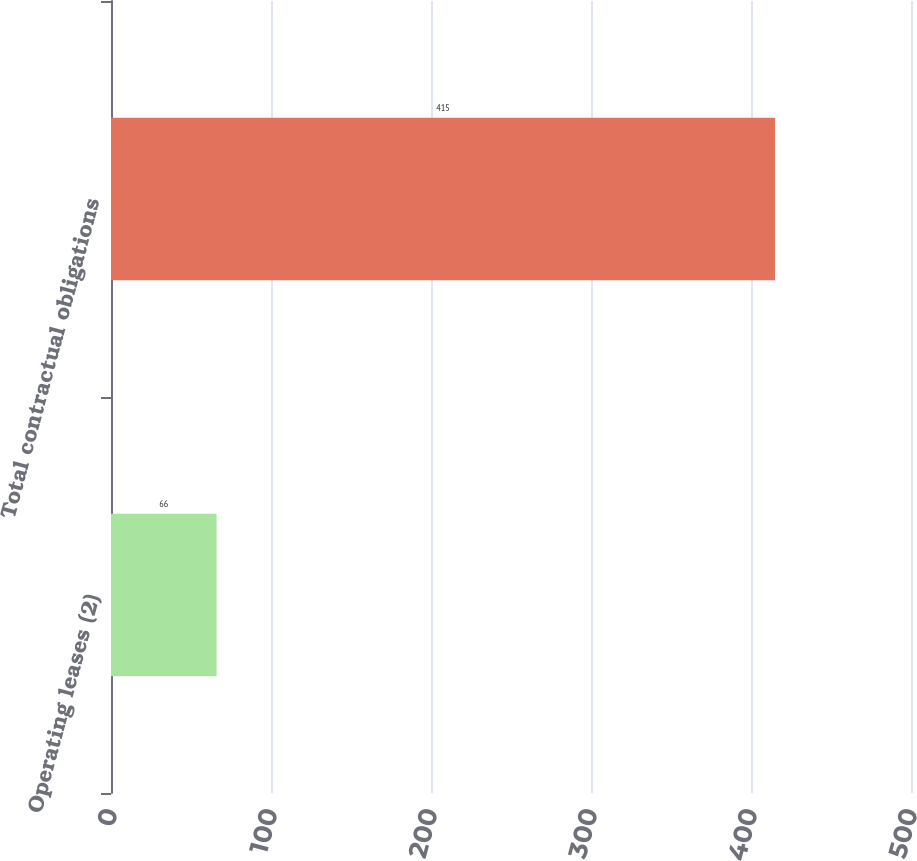Convert chart to OTSL. <chart><loc_0><loc_0><loc_500><loc_500><bar_chart><fcel>Operating leases (2)<fcel>Total contractual obligations<nl><fcel>66<fcel>415<nl></chart> 